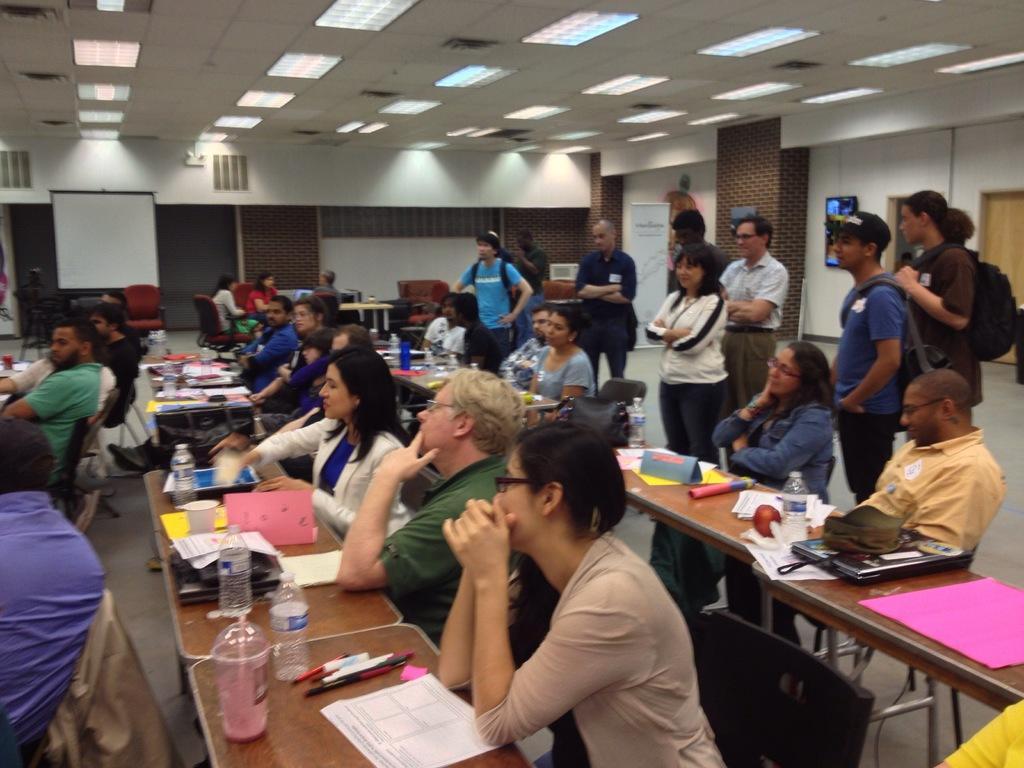Please provide a concise description of this image. This image is clicked in a room. There are so many tables and chairs, people are sitting on the chair ,some people are standing on the right side and the lights are on the top. There is door on the right side. There is white board on the left side. There are water bottles, pens ,papers, books and laptops, fruits on that tables. 